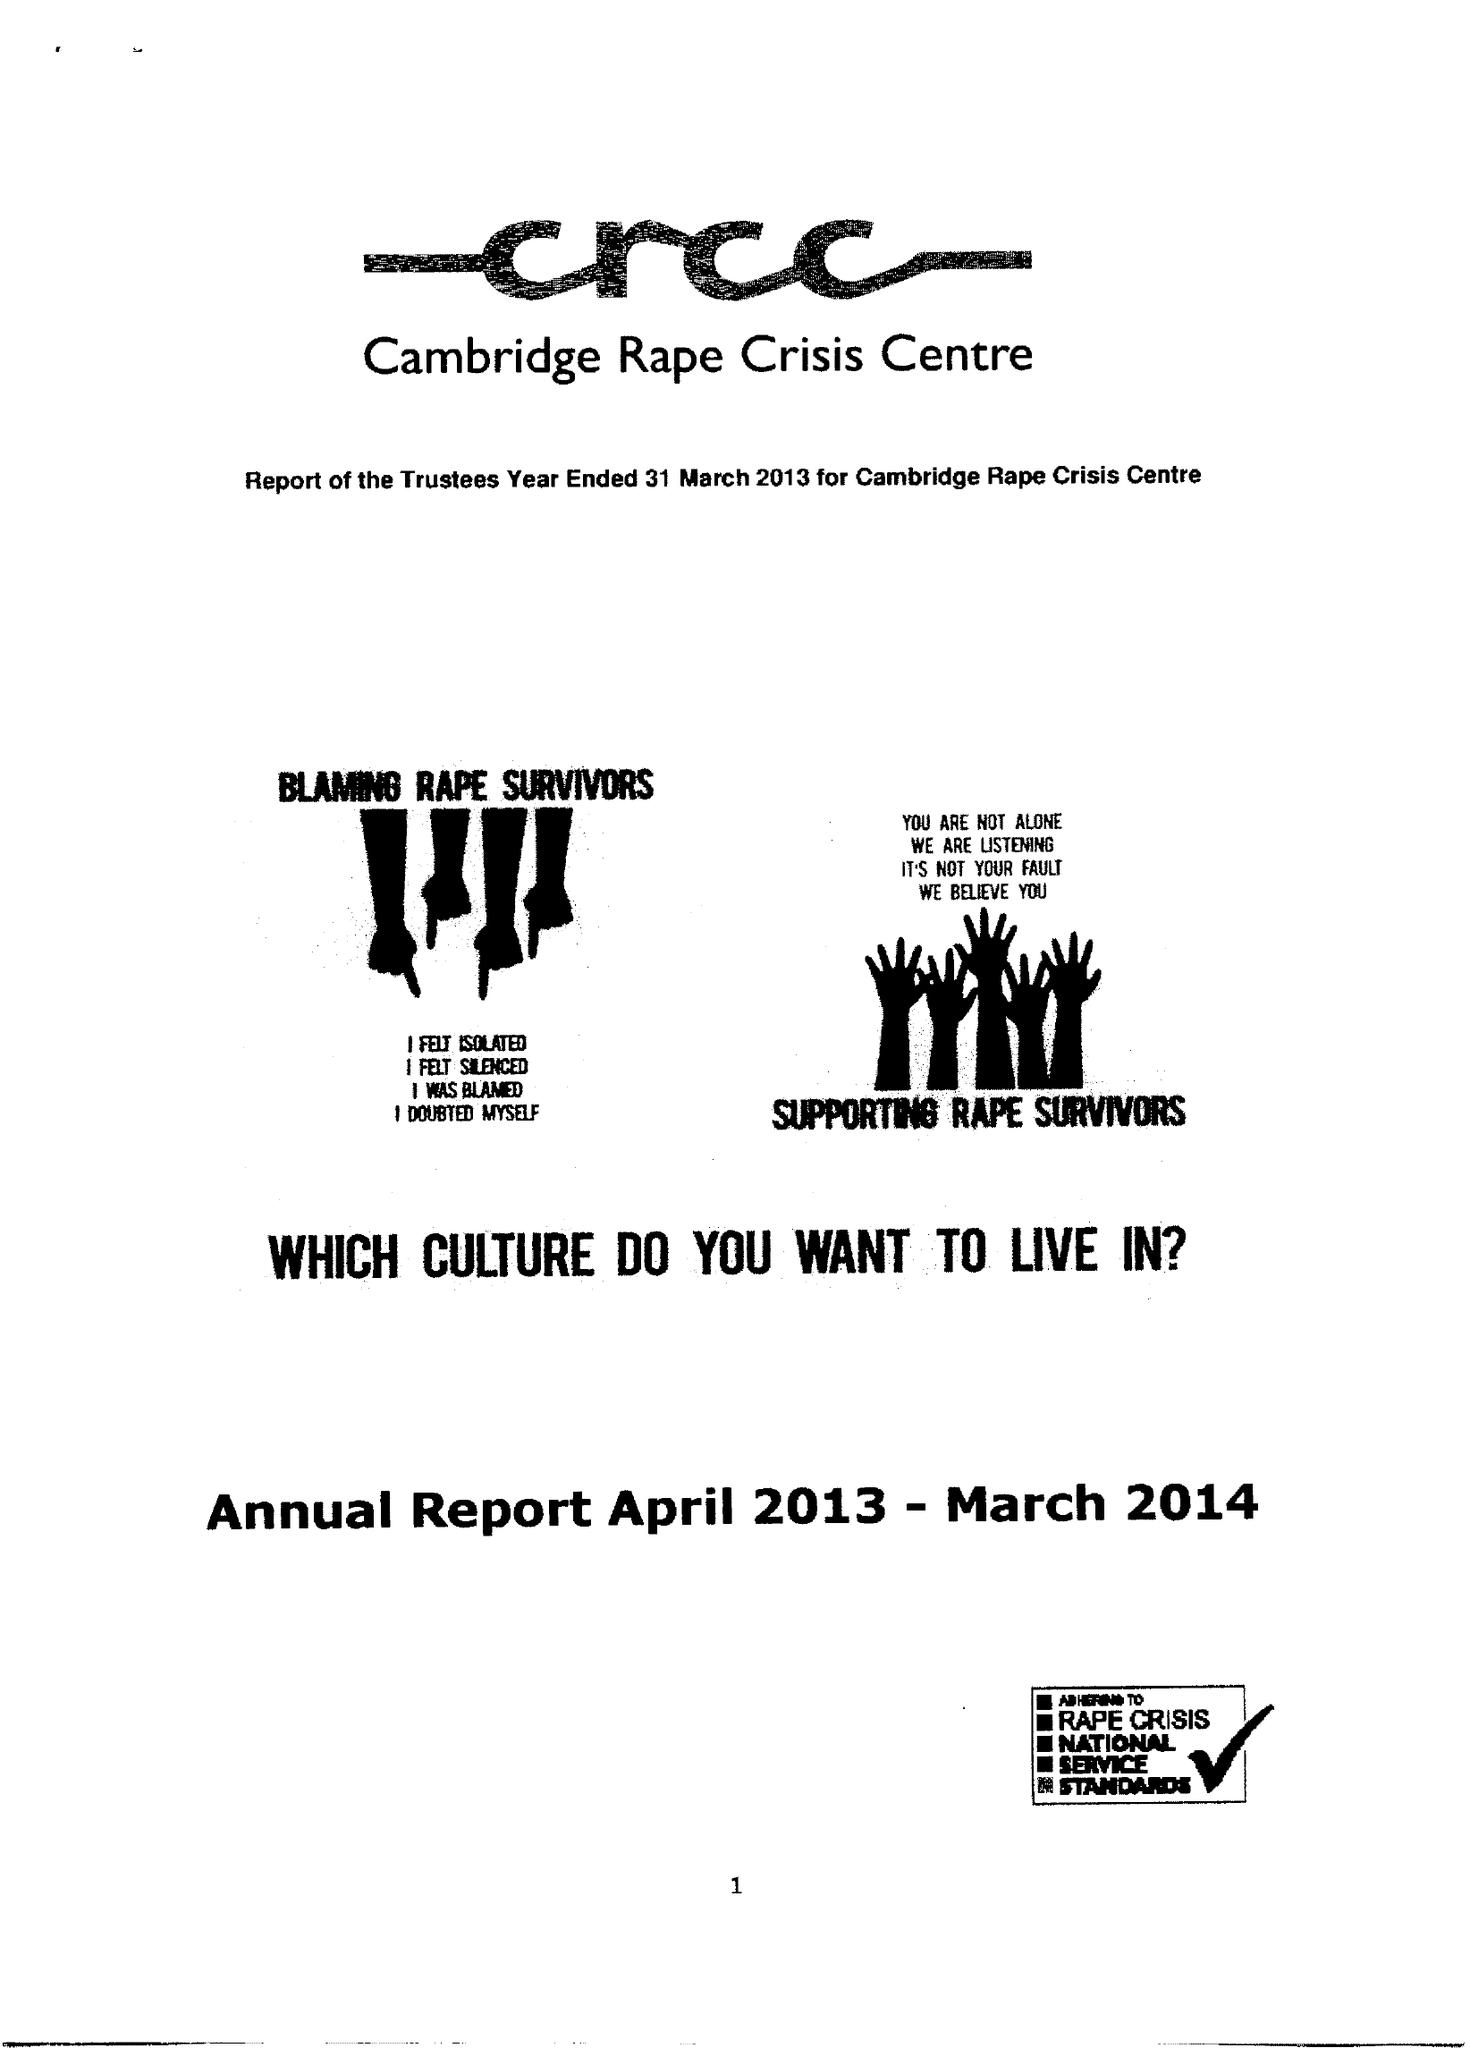What is the value for the spending_annually_in_british_pounds?
Answer the question using a single word or phrase. 84741.00 